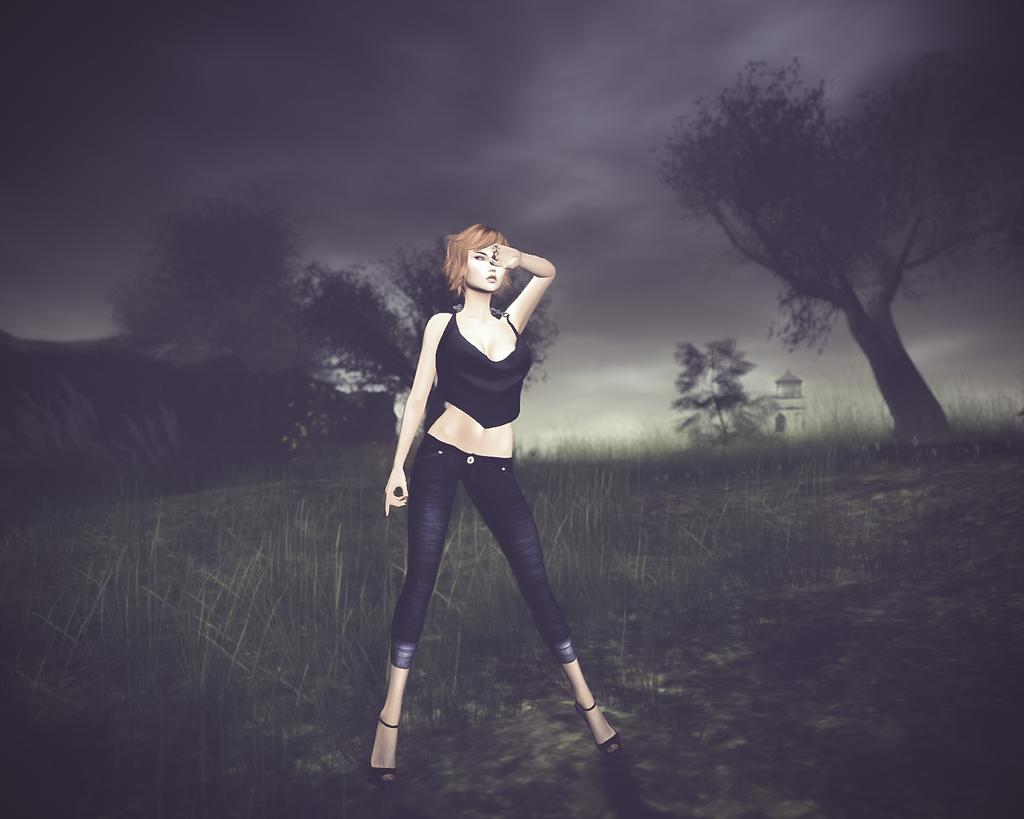How has the image been altered or modified? The image is edited. What is the main subject in the center of the image? There is a woman standing in the center of the image. What type of vegetation can be seen in the image? There is grass visible in the image, and there are also trees. What is the weather like in the image? The sky is cloudy in the image. What type of nail is the woman using to teach her brother in the image? There is no nail or teaching activity present in the image. 